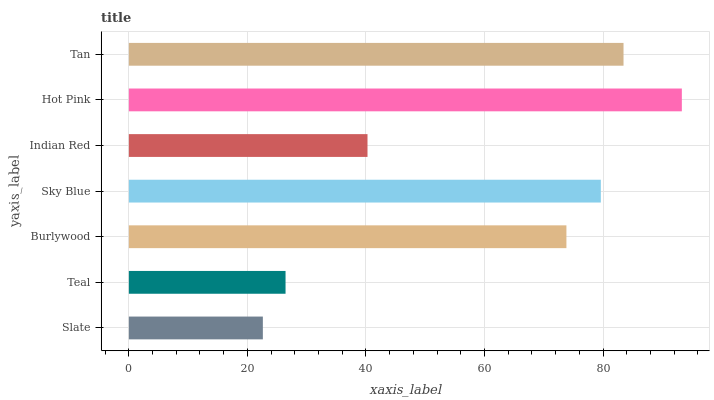Is Slate the minimum?
Answer yes or no. Yes. Is Hot Pink the maximum?
Answer yes or no. Yes. Is Teal the minimum?
Answer yes or no. No. Is Teal the maximum?
Answer yes or no. No. Is Teal greater than Slate?
Answer yes or no. Yes. Is Slate less than Teal?
Answer yes or no. Yes. Is Slate greater than Teal?
Answer yes or no. No. Is Teal less than Slate?
Answer yes or no. No. Is Burlywood the high median?
Answer yes or no. Yes. Is Burlywood the low median?
Answer yes or no. Yes. Is Sky Blue the high median?
Answer yes or no. No. Is Sky Blue the low median?
Answer yes or no. No. 